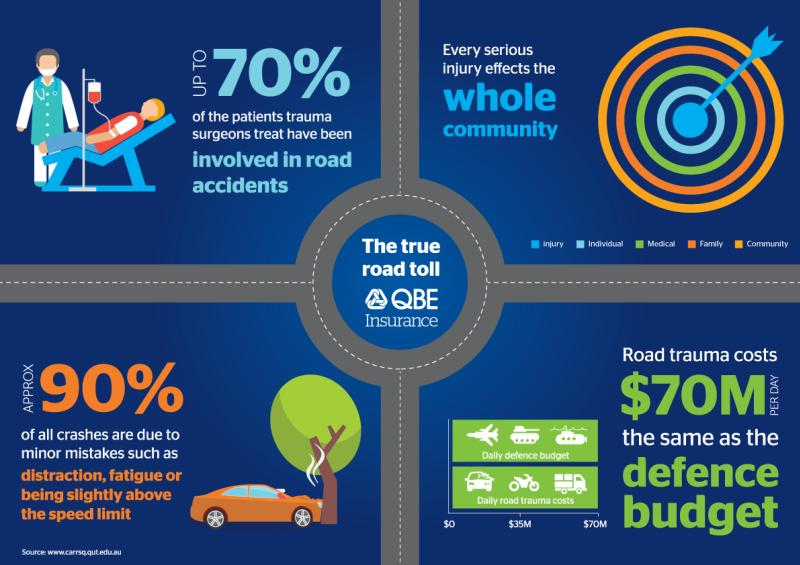Outline some significant characteristics in this image. In 10% of crashes, major mistakes are found to be the primary cause. Green is the color used to represent medical-blue, green, orange, or white. 